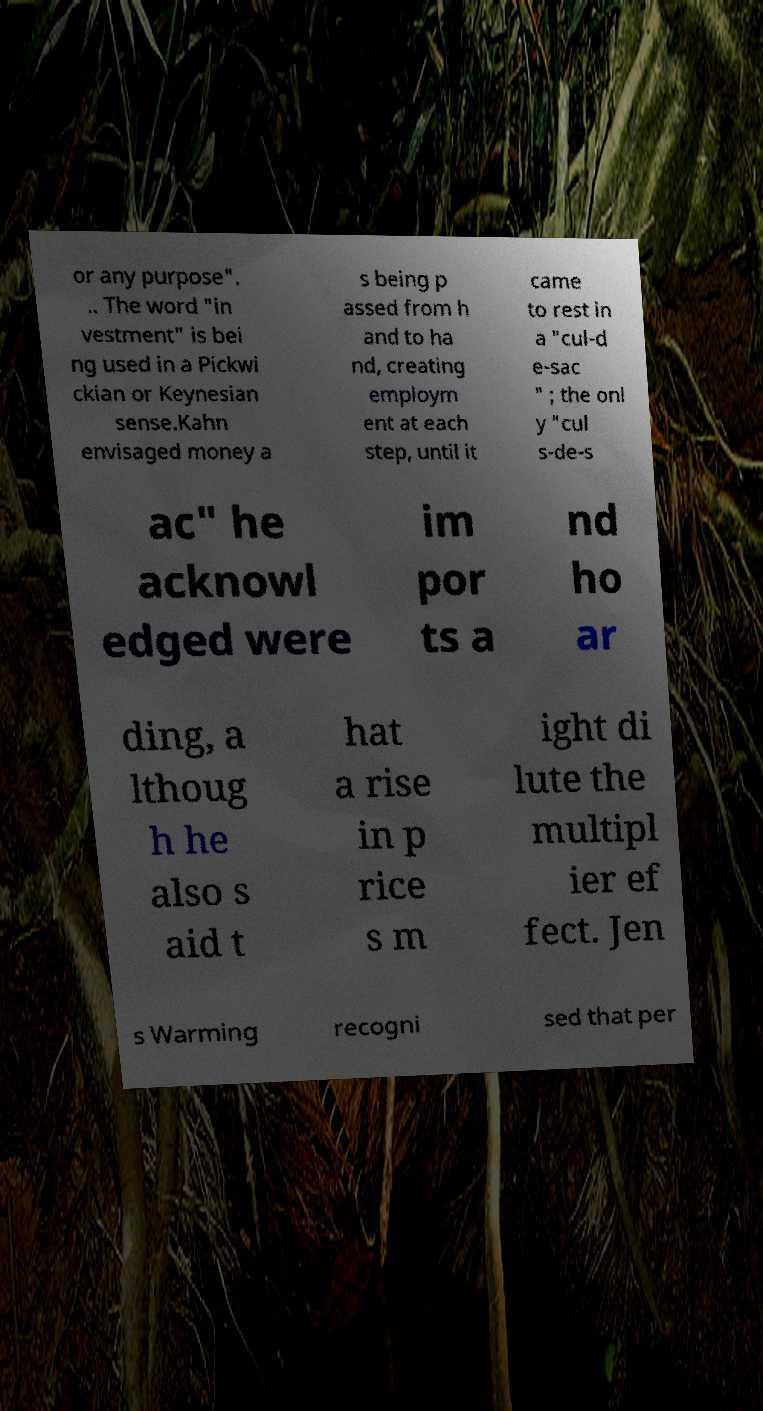For documentation purposes, I need the text within this image transcribed. Could you provide that? or any purpose". .. The word "in vestment" is bei ng used in a Pickwi ckian or Keynesian sense.Kahn envisaged money a s being p assed from h and to ha nd, creating employm ent at each step, until it came to rest in a "cul-d e-sac " ; the onl y "cul s-de-s ac" he acknowl edged were im por ts a nd ho ar ding, a lthoug h he also s aid t hat a rise in p rice s m ight di lute the multipl ier ef fect. Jen s Warming recogni sed that per 